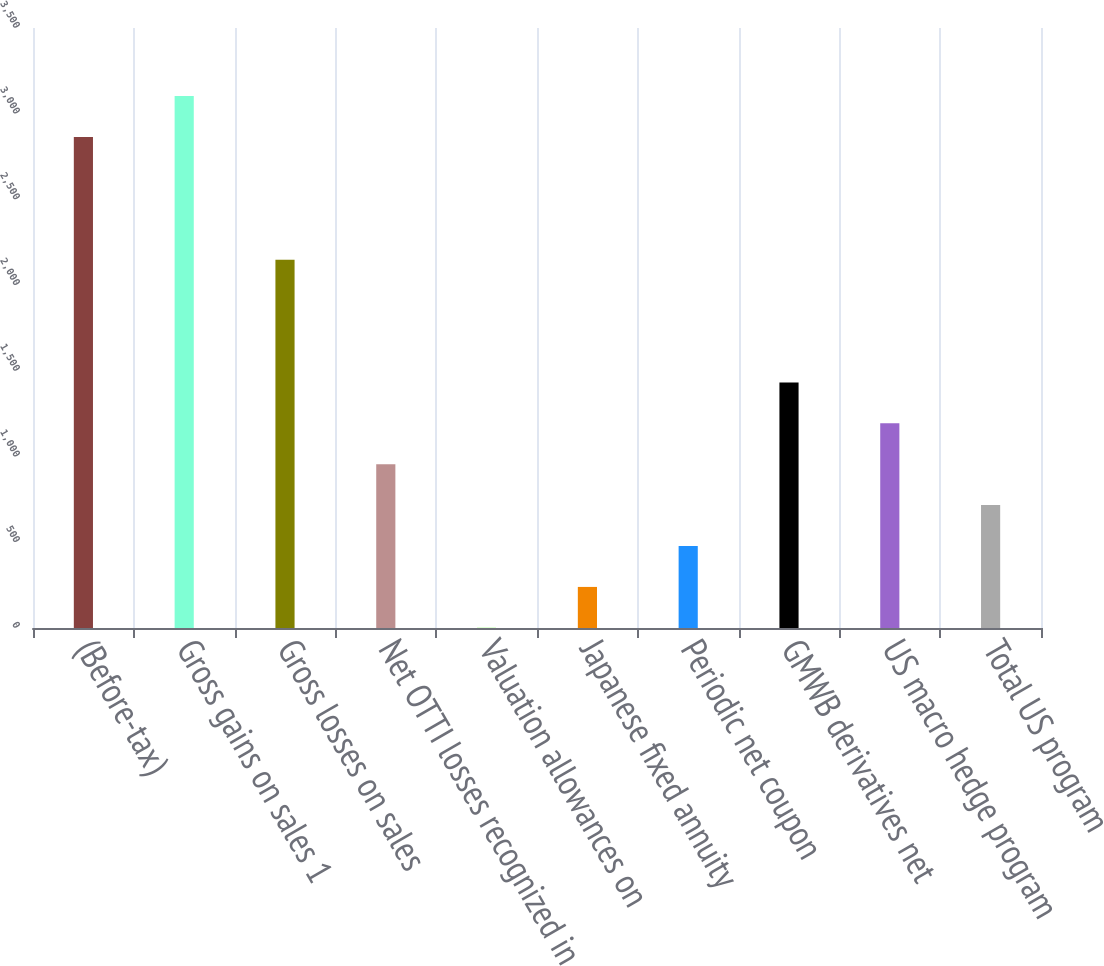Convert chart to OTSL. <chart><loc_0><loc_0><loc_500><loc_500><bar_chart><fcel>(Before-tax)<fcel>Gross gains on sales 1<fcel>Gross losses on sales<fcel>Net OTTI losses recognized in<fcel>Valuation allowances on<fcel>Japanese fixed annuity<fcel>Periodic net coupon<fcel>GMWB derivatives net<fcel>US macro hedge program<fcel>Total US program<nl><fcel>2864.2<fcel>3102.8<fcel>2148.4<fcel>955.4<fcel>1<fcel>239.6<fcel>478.2<fcel>1432.6<fcel>1194<fcel>716.8<nl></chart> 